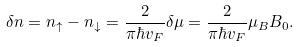<formula> <loc_0><loc_0><loc_500><loc_500>\delta n = n _ { \uparrow } - n _ { \downarrow } = \frac { 2 } { \pi \hbar { v } _ { F } } \delta \mu = \frac { 2 } { \pi \hbar { v } _ { F } } \mu _ { B } B _ { 0 } .</formula> 